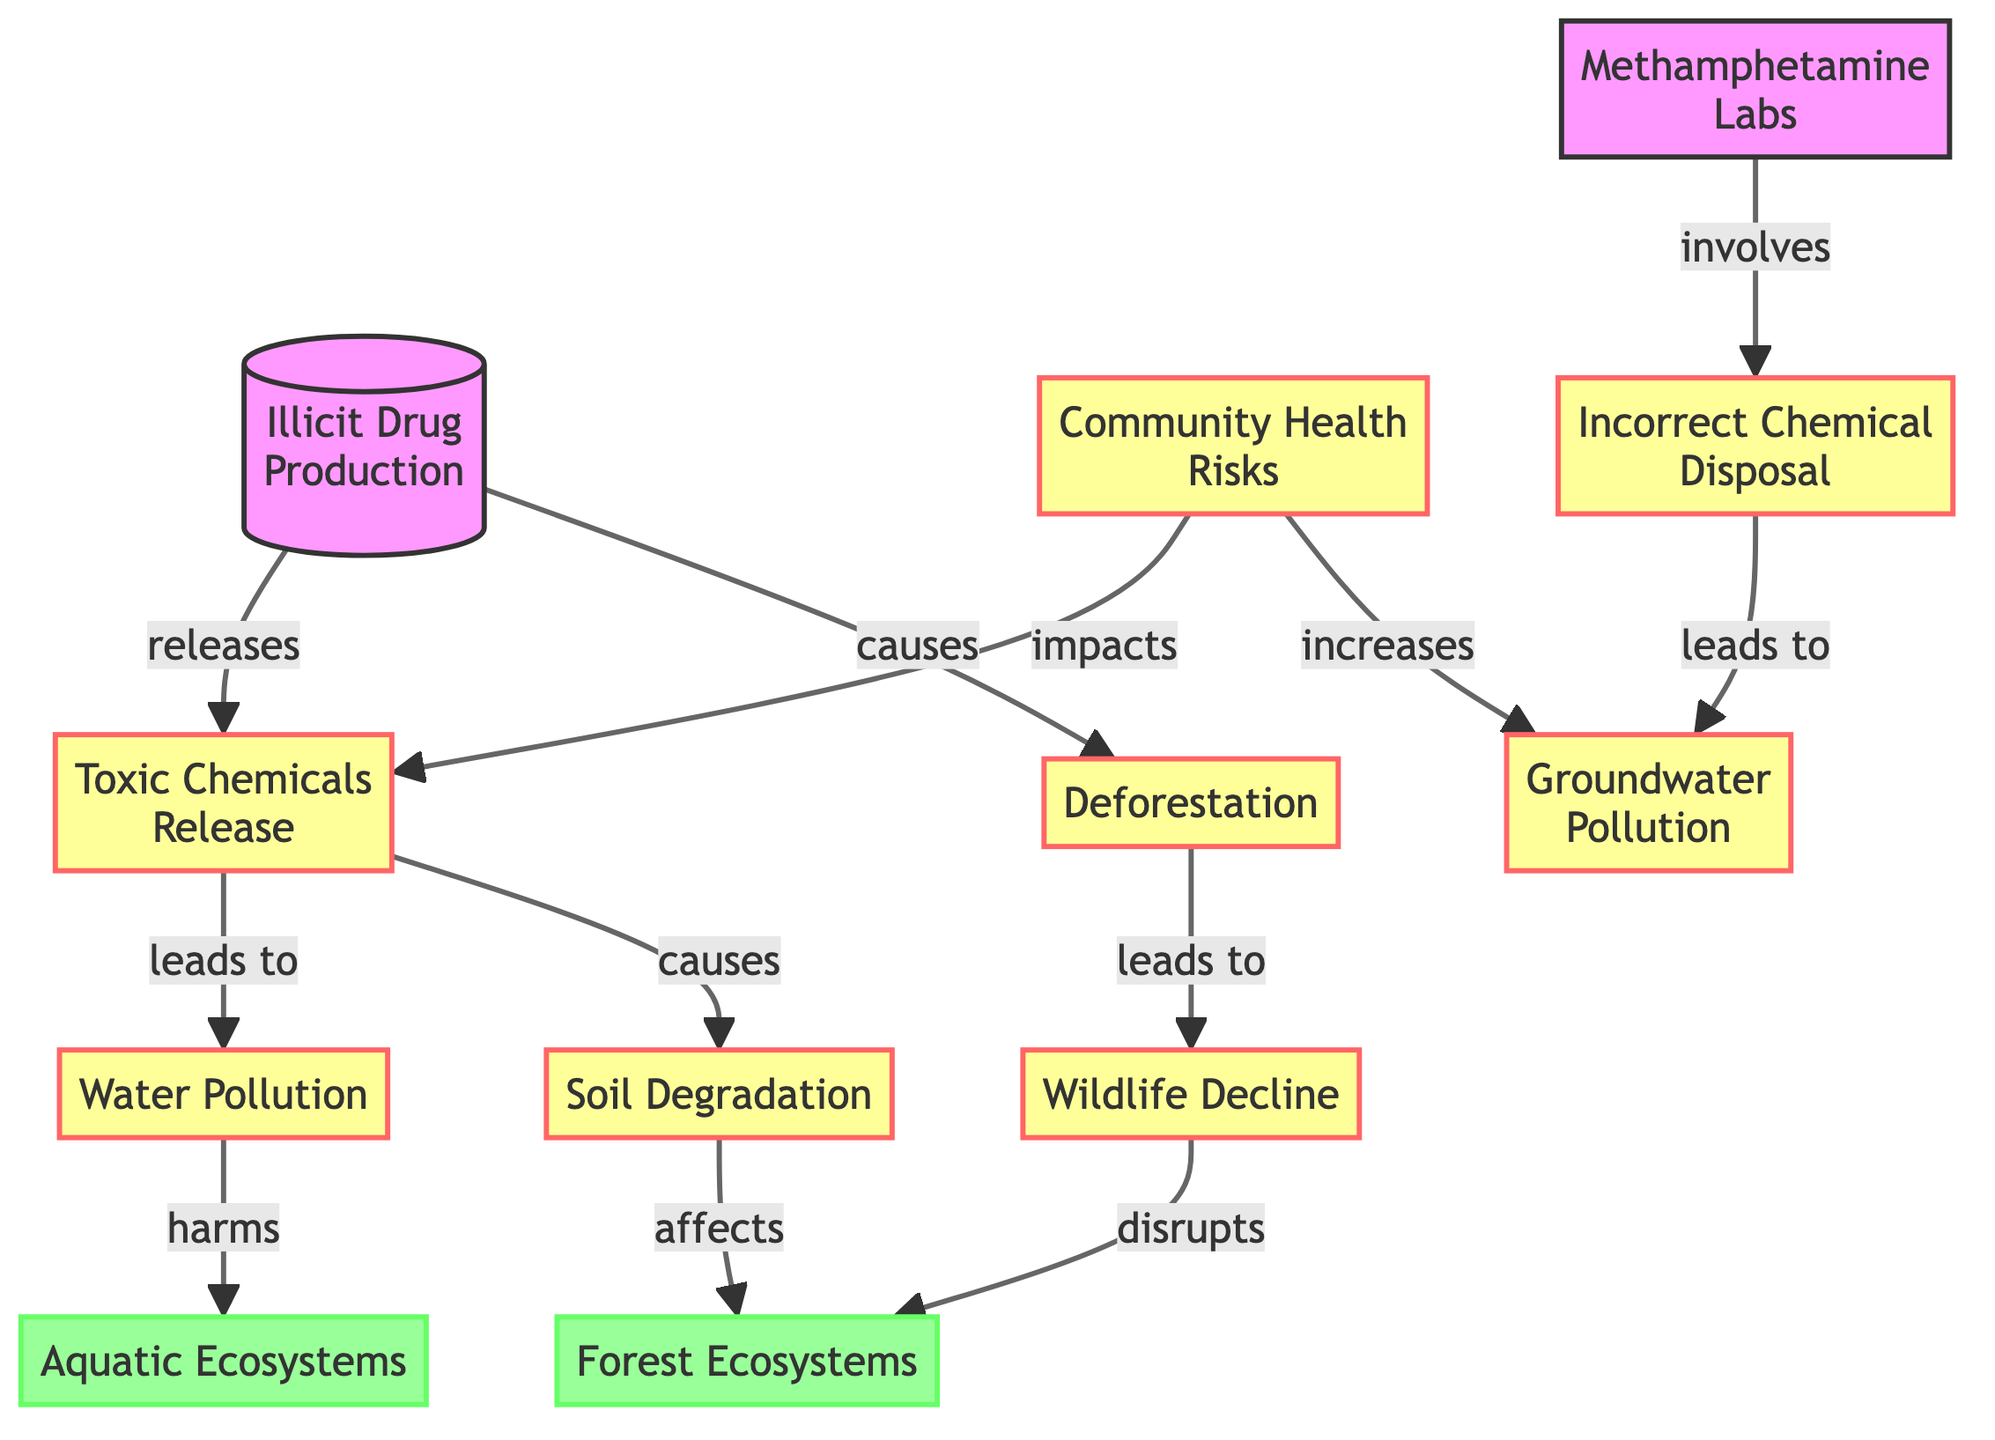What is released by illicit drug production? According to the diagram, illicit drug production leads to the release of toxic chemicals. This is represented by the edge from "Illicit Drug Production" to "Toxic Chemicals".
Answer: Toxic Chemicals What environmental issue does deforestation lead to? The diagram shows that deforestation leads to wildlife decline. This relationship is established with an arrow from "Deforestation" to "Wildlife Decline".
Answer: Wildlife Decline How many impacts are listed in the diagram? There are six environmental impacts shown in the diagram, represented by the nodes following illicit drug production: toxic chemicals release, deforestation, water pollution, soil degradation, wildlife decline, and community health risks.
Answer: Six Which ecosystems are affected by water pollution? The diagram indicates that water pollution harms aquatic ecosystems. The arrow from "Water Pollution" to "Aquatic Ecosystems" demonstrates this direct impact.
Answer: Aquatic Ecosystems What is the connection between chemical disposal and groundwater pollution? The diagram illustrates that chemical disposal leads to groundwater pollution. There is an arrow indicating this cause-and-effect relationship, showing how improper disposal affects groundwater.
Answer: Groundwater Pollution How does community health relate to groundwater pollution? In the diagram, there is a direct connection where community health impacts groundwater pollution. The arrow indicates that issues related to community health can increase pollution in groundwater sources.
Answer: Increases What type of ecosystems are affected by soil degradation? The diagram specifies that soil degradation affects forest ecosystems, shown by the arrow leading from "Soil Degradation" to "Forest Ecosystems".
Answer: Forest Ecosystems Which node represents the incorrect management of chemicals? The node titled "Incorrect Chemical Disposal" represents the issue of mismanaging chemicals, connected to the meth labs section of the diagram.
Answer: Incorrect Chemical Disposal What is the relationship between toxic chemicals and water pollution? The diagram reveals that toxic chemicals lead to water pollution, demonstrated by the arrow going from "Toxic Chemicals" to "Water Pollution". This indicates that the release of toxic chemicals has a direct impact on water quality.
Answer: Leads to 